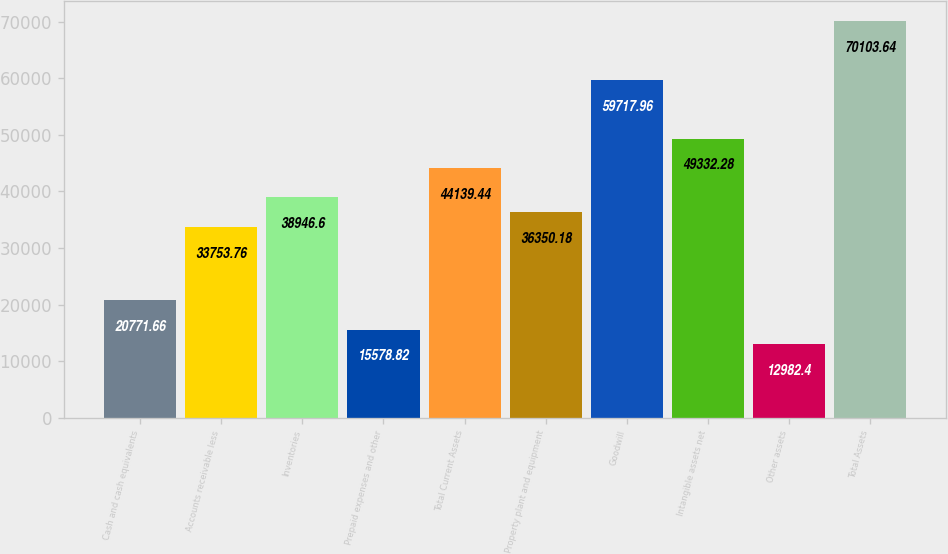Convert chart to OTSL. <chart><loc_0><loc_0><loc_500><loc_500><bar_chart><fcel>Cash and cash equivalents<fcel>Accounts receivable less<fcel>Inventories<fcel>Prepaid expenses and other<fcel>Total Current Assets<fcel>Property plant and equipment<fcel>Goodwill<fcel>Intangible assets net<fcel>Other assets<fcel>Total Assets<nl><fcel>20771.7<fcel>33753.8<fcel>38946.6<fcel>15578.8<fcel>44139.4<fcel>36350.2<fcel>59718<fcel>49332.3<fcel>12982.4<fcel>70103.6<nl></chart> 